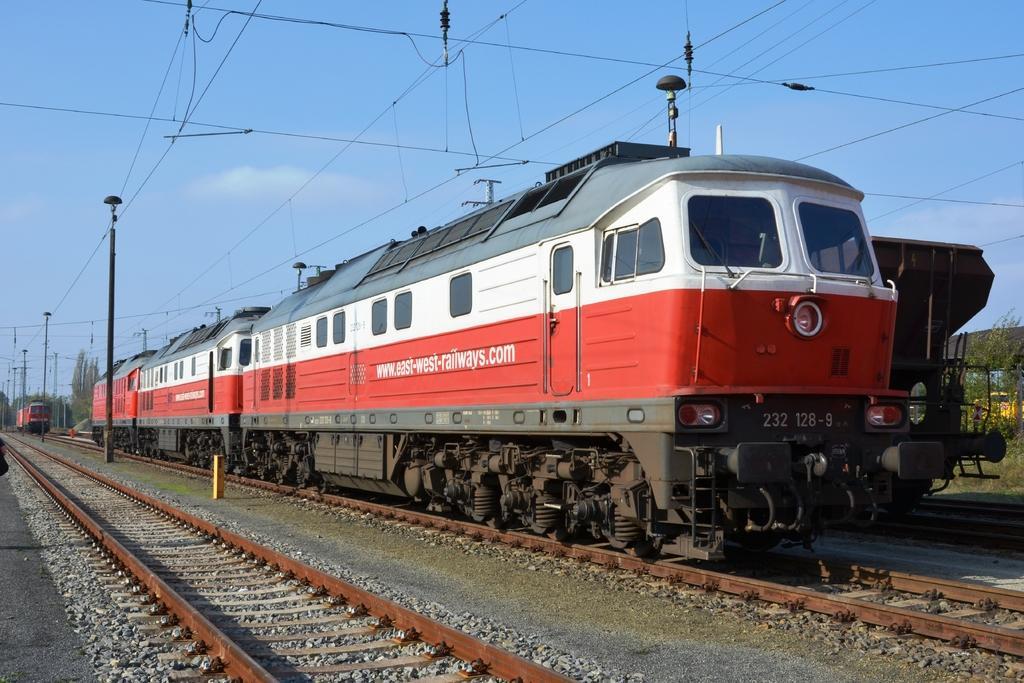Please provide a concise description of this image. In this image I can see few trains on the railway-track. Train in white, red and ash color. I can see few poles, wires, plants and sky is in white and blue color. 